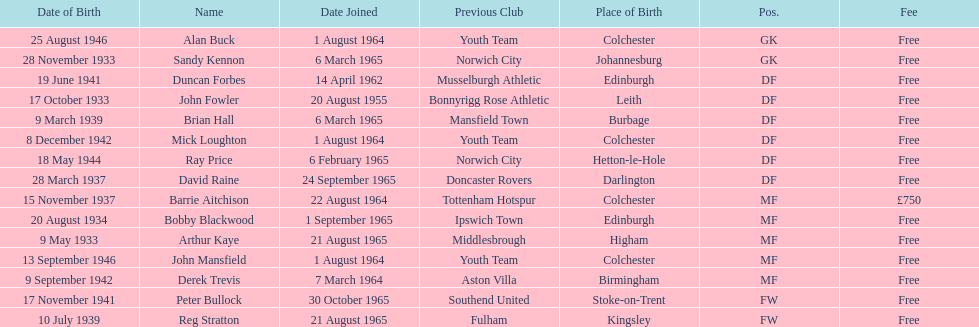How many players are listed as df? 6. 